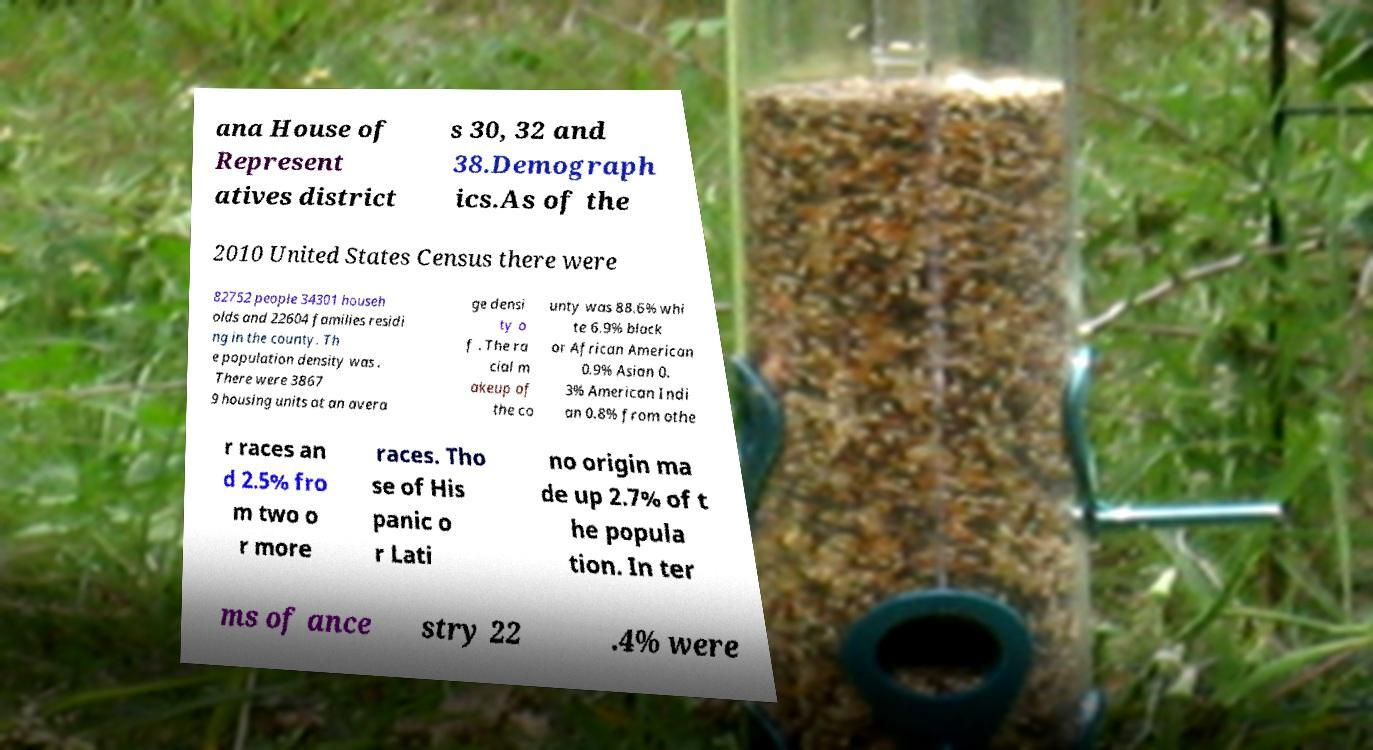What messages or text are displayed in this image? I need them in a readable, typed format. ana House of Represent atives district s 30, 32 and 38.Demograph ics.As of the 2010 United States Census there were 82752 people 34301 househ olds and 22604 families residi ng in the county. Th e population density was . There were 3867 9 housing units at an avera ge densi ty o f . The ra cial m akeup of the co unty was 88.6% whi te 6.9% black or African American 0.9% Asian 0. 3% American Indi an 0.8% from othe r races an d 2.5% fro m two o r more races. Tho se of His panic o r Lati no origin ma de up 2.7% of t he popula tion. In ter ms of ance stry 22 .4% were 